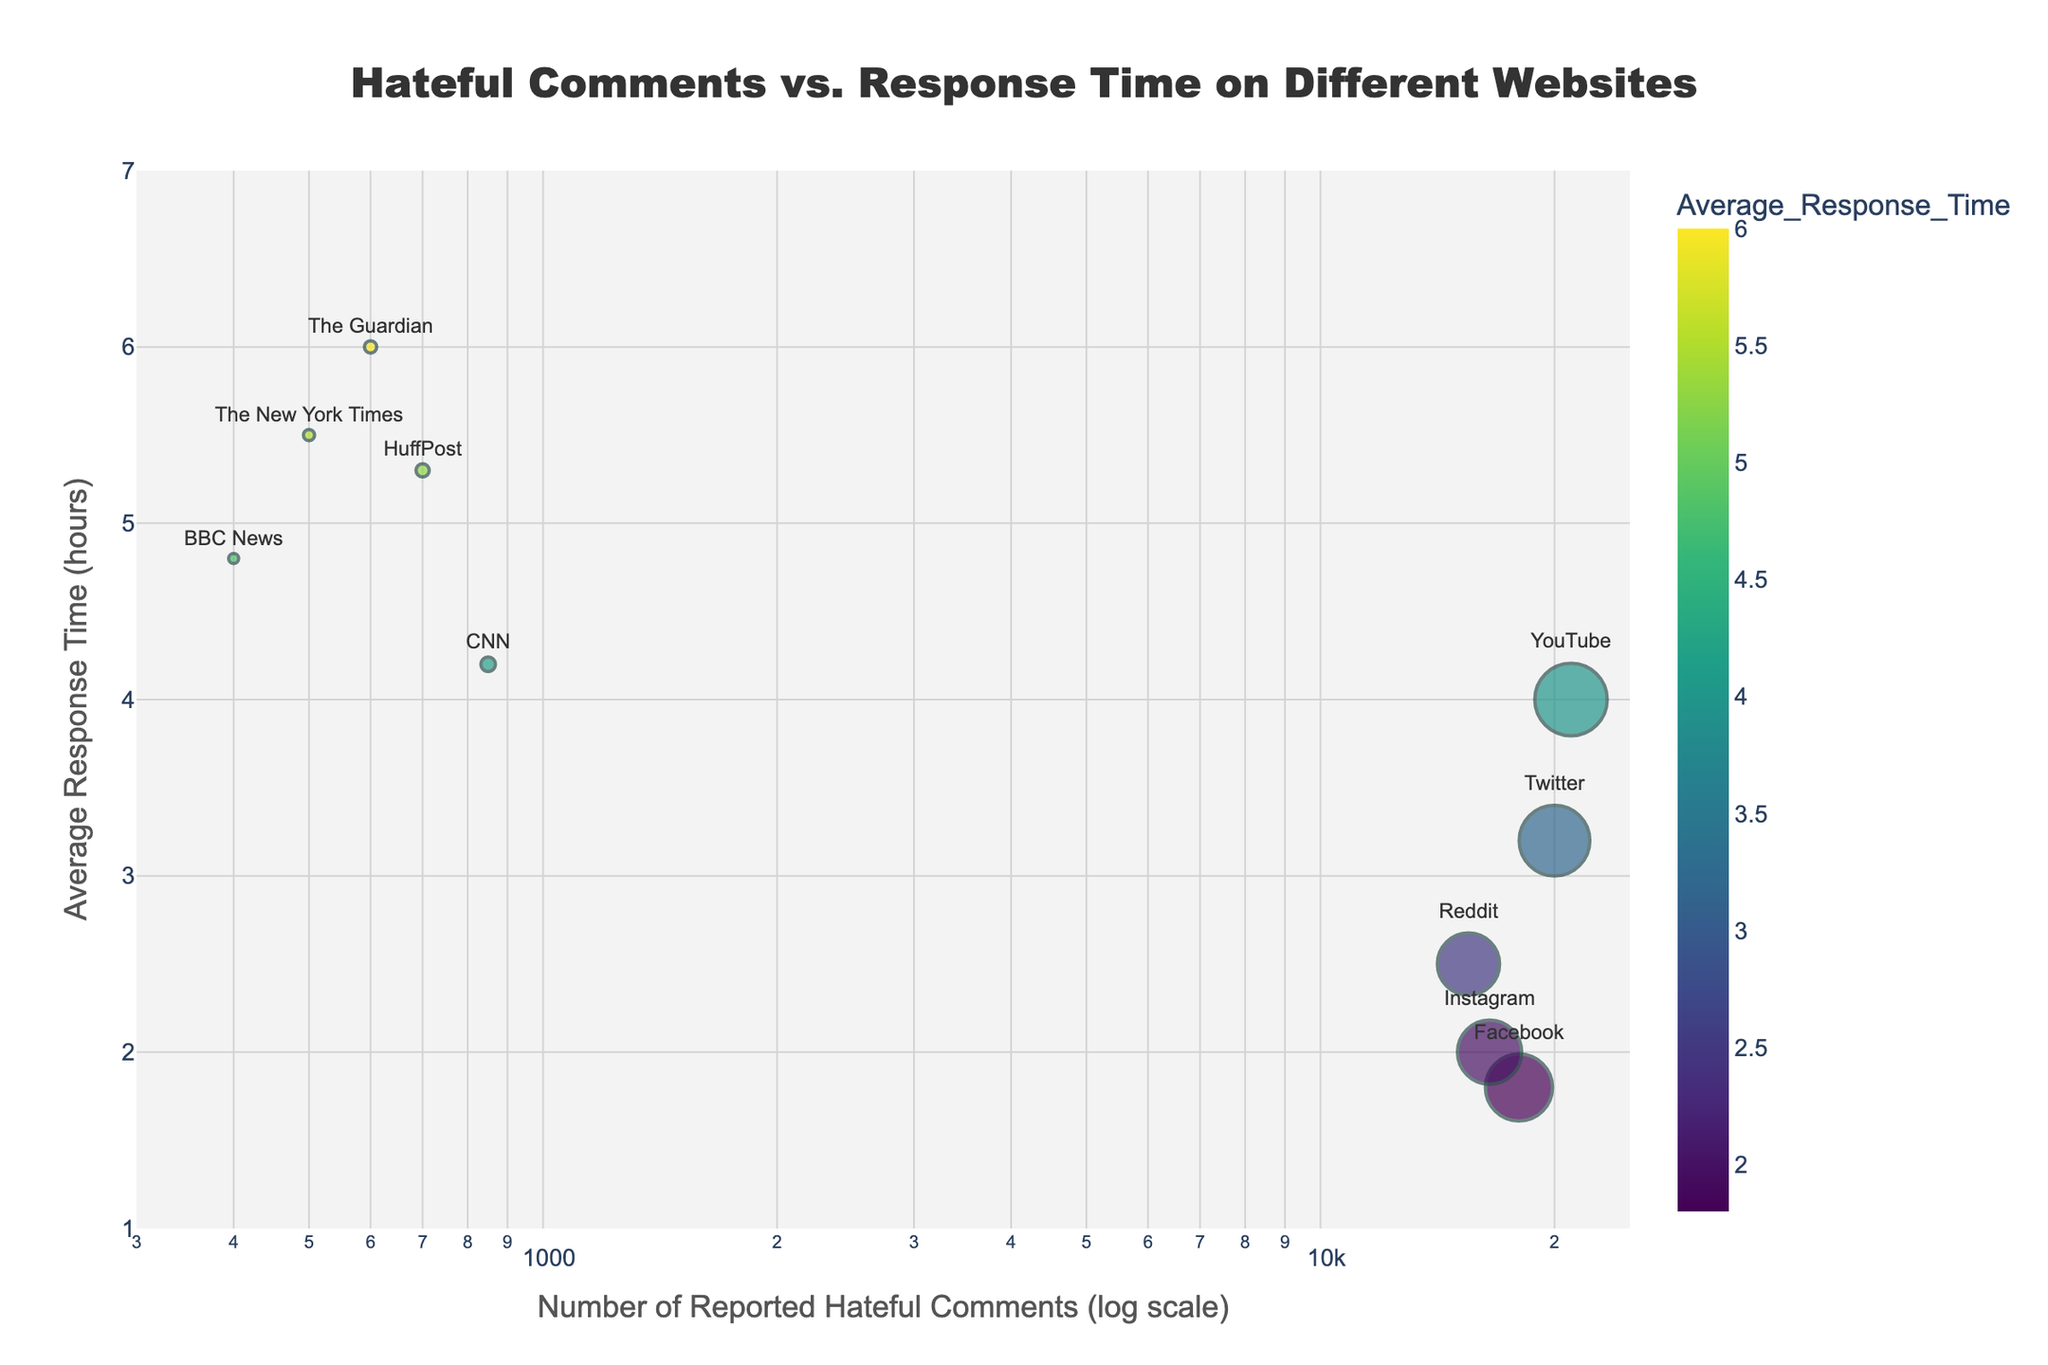How many websites are analyzed in the scatter plot? Count the number of unique data points in the scatter plot. Each website corresponds to one data point.
Answer: 10 What is the title of the scatter plot? The title is displayed at the top of the scatter plot.
Answer: Hateful Comments vs. Response Time on Different Websites What is the log-scale range of the x-axis? Look at the ticks on the x-axis to identify the range. The range is given in logarithmic scale.
Answer: 300 to 25000 Which website experiences the highest number of reported hateful comments? Identify the data point with the highest value on the x-axis (log scale).
Answer: YouTube Which website has the longest average response time? Identify the data point placed highest on the y-axis (represents average response time).
Answer: The Guardian What is the average response time for Facebook? Find the data point labeled 'Facebook' and check its y-axis value.
Answer: 1.8 hours Which website has fewer reported hateful comments: CNN or HuffPost? Compare the x-axis values (number of reported hateful comments) for CNN and HuffPost.
Answer: HuffPost Which website has the shortest average response time and how many hateful comments does it report? Identify the data point placed lowest on the y-axis and check its x-axis value.
Answer: Facebook, 18000 What is the response time difference between Reddit and Instagram? Subtract the average response time of Instagram from that of Reddit.
Answer: 2.5 - 2.0 = 0.5 hours If you sum the average response times of The New York Times, The Guardian, and BBC News, what is the total? Add the y-axis values of The New York Times (5.5), The Guardian (6.0), and BBC News (4.8).
Answer: 5.5 + 6.0 + 4.8 = 16.3 hours 